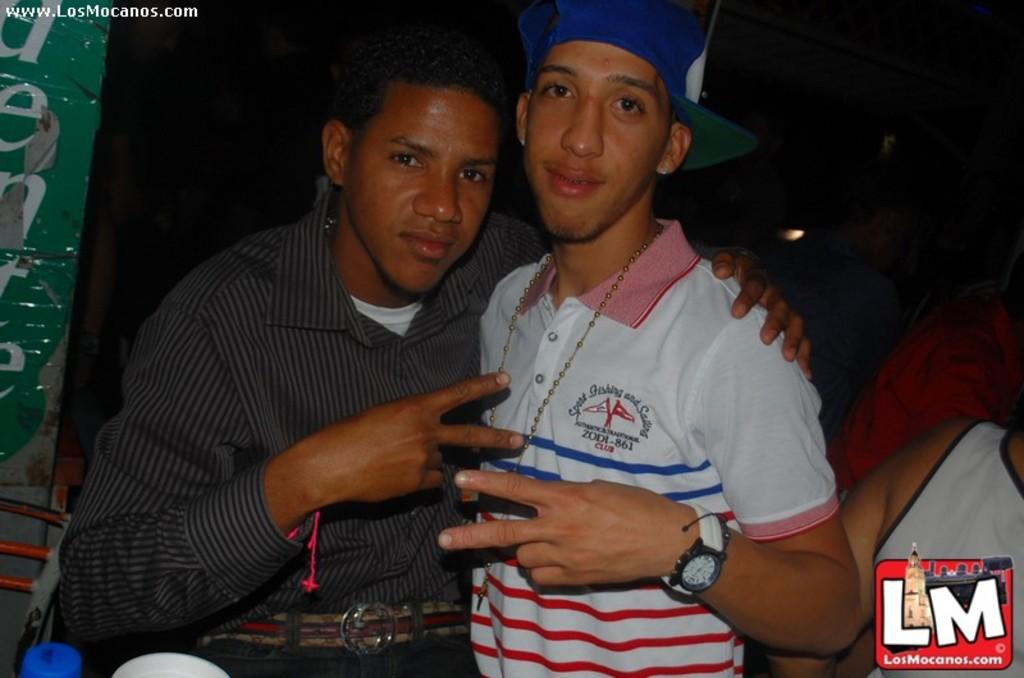<image>
Write a terse but informative summary of the picture. Two men are posing in a pitcure from LM.com 